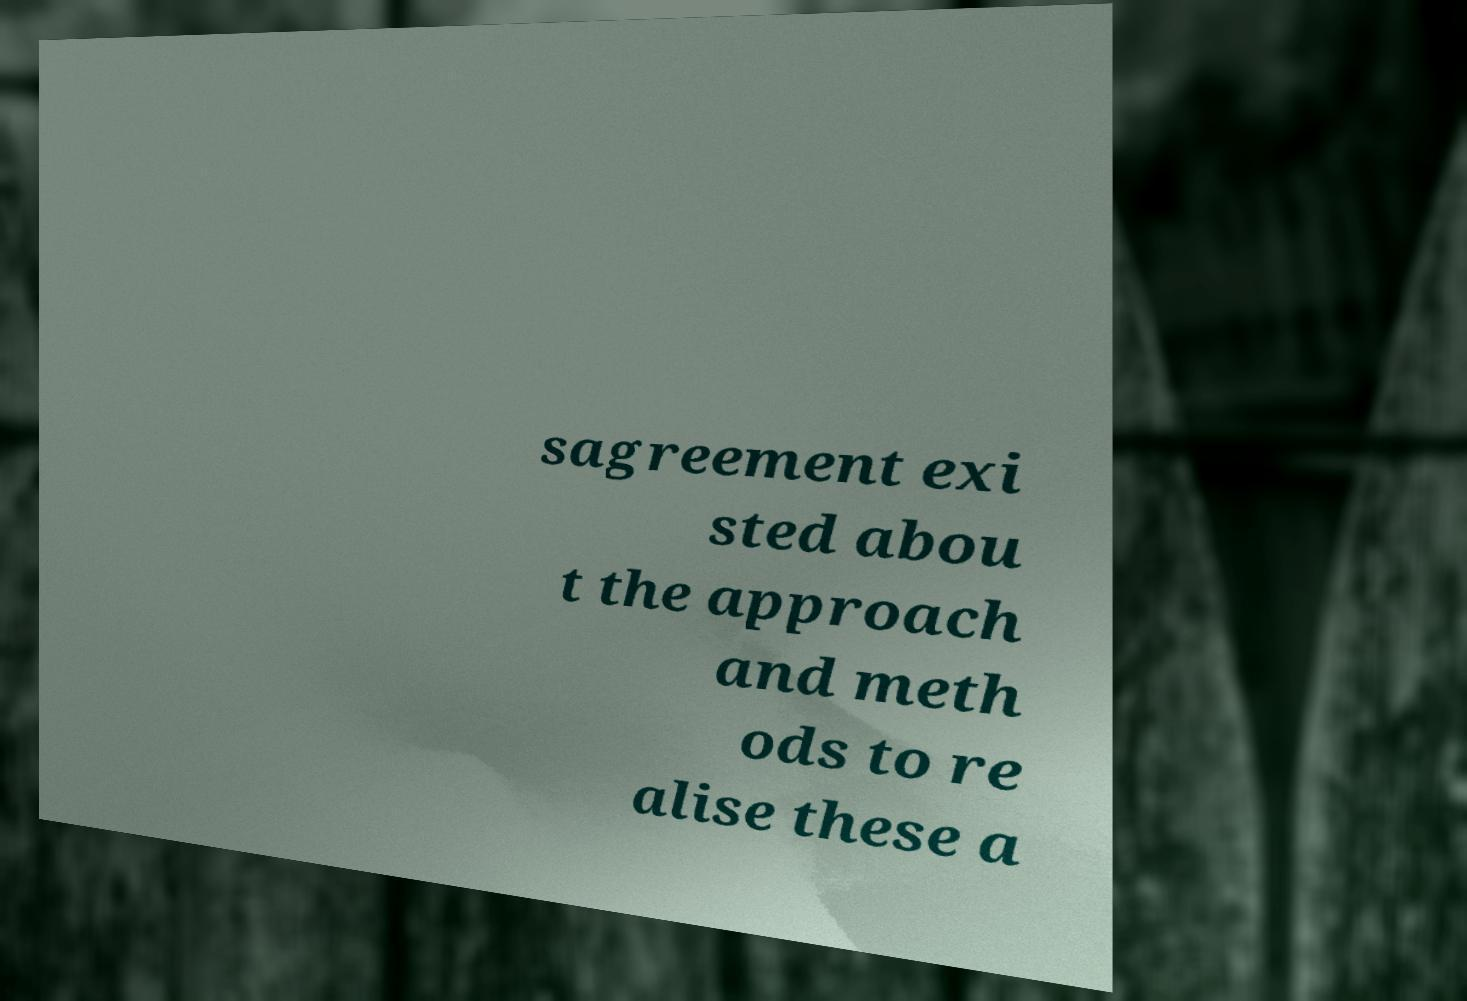I need the written content from this picture converted into text. Can you do that? sagreement exi sted abou t the approach and meth ods to re alise these a 